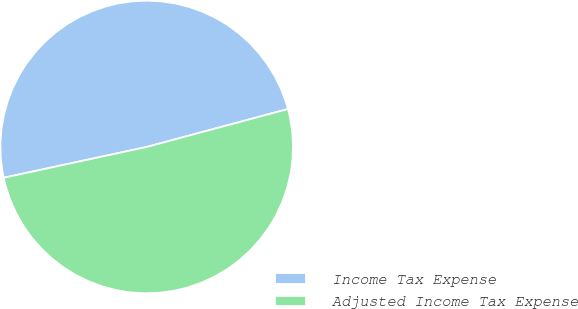Convert chart. <chart><loc_0><loc_0><loc_500><loc_500><pie_chart><fcel>Income Tax Expense<fcel>Adjusted Income Tax Expense<nl><fcel>49.2%<fcel>50.8%<nl></chart> 